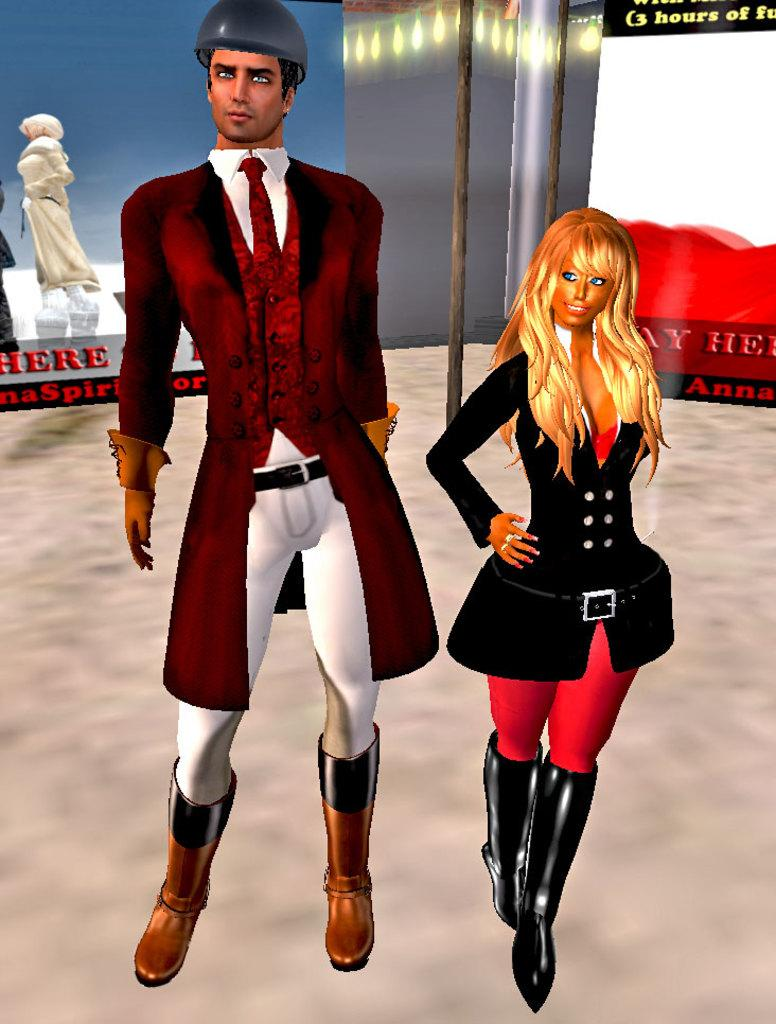What type of characters are depicted in the image? There is a cartoon picture of a man and a cartoon picture of a woman in the image. What can be seen in addition to the characters in the image? There is text visible in the image. What type of stitch is used to create the woman's dress in the image? There is no stitching present in the image, as it is a cartoon picture and not a real-life scene. 